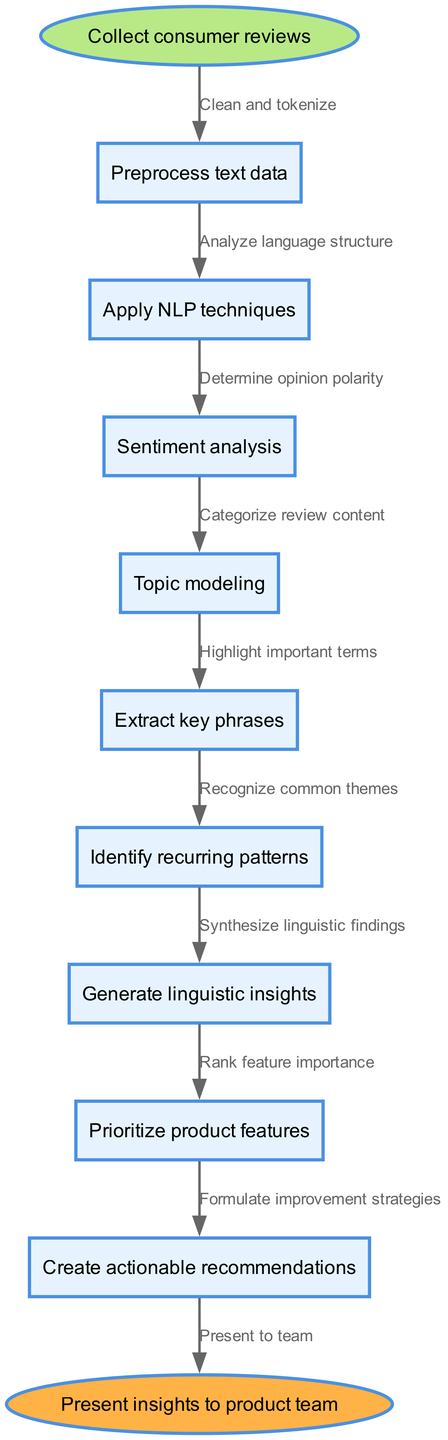What is the starting point of the process? The diagram indicates that the starting point is labeled "Collect consumer reviews."
Answer: Collect consumer reviews How many nodes are there in the diagram? Counting the start, end, and process nodes, there are a total of 10 nodes in the diagram.
Answer: 10 What is the last process before presenting insights? The last process node before presenting insights is "Create actionable recommendations."
Answer: Create actionable recommendations Which technique is used immediately after preprocessing text data? The diagram shows that "Apply NLP techniques" follows directly after "Preprocess text data."
Answer: Apply NLP techniques What is the result of performing sentiment analysis? After sentiment analysis, the next logical step indicated in the diagram is to "Determine opinion polarity."
Answer: Determine opinion polarity Which two processes are linked to the identification of patterns? The diagram shows that "Identify recurring patterns" is linked both to "Extract key phrases" and "Generate linguistic insights."
Answer: Extract key phrases, Generate linguistic insights How are product features prioritized in this flow? The prioritization of product features occurs in the "Prioritize product features" step following "Identify recurring patterns."
Answer: Prioritize product features What leads to the formulation of improvement strategies? The step leading to the formulation of improvement strategies is "Create actionable recommendations," which comes after prioritizing product features.
Answer: Create actionable recommendations What connects the start node to the first process node? The connection between the start node and the first process node is described by the edge labeled "Clean and tokenize."
Answer: Clean and tokenize 